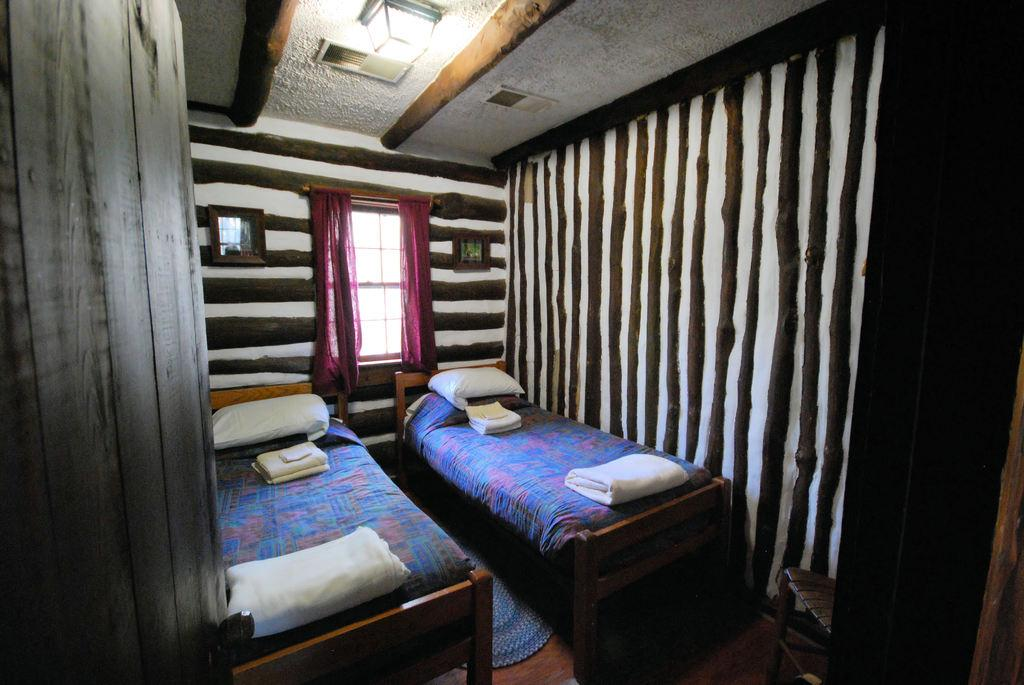How many beds are in the image? There are two beds in the image. What can be seen on top of the beds? There are white pillows on the beds. What color are the curtains in the image? The curtains are maroon in color. How would you describe the color of the wall in the image? The wall has a combination of white and brown colors. Can you identify a source of light in the image? Yes, there is a light visible in the image. How many bananas are on the part of the account in the image? There are no bananas, parts, or accounts present in the image. 